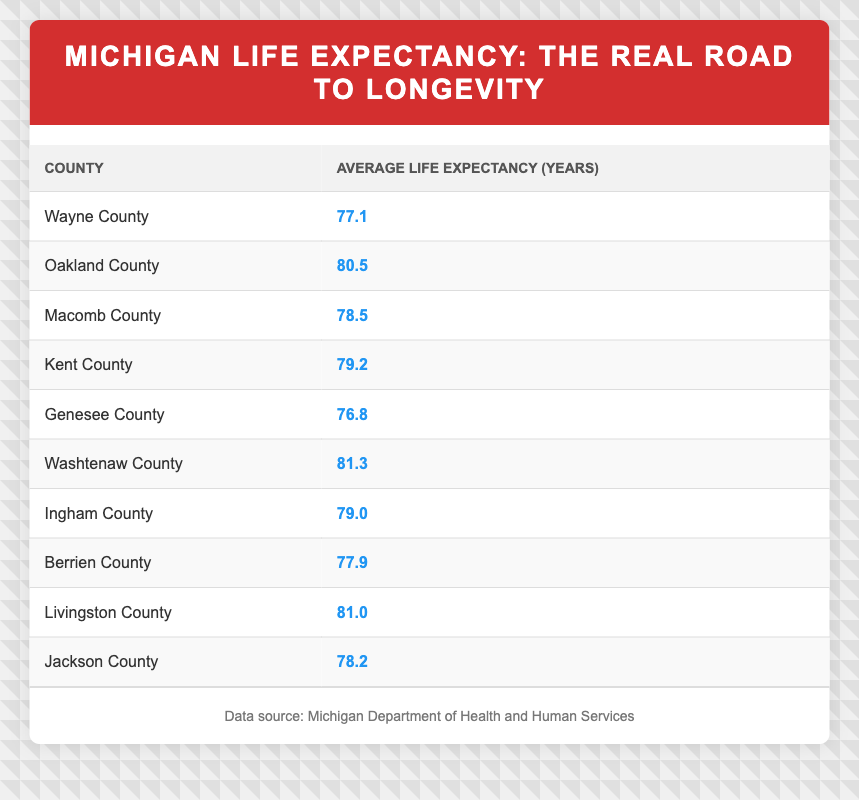What is the average life expectancy in Wayne County? The table states that the average life expectancy for Wayne County is 77.1 years.
Answer: 77.1 How does the average life expectancy in Oakland County compare to that in Genesee County? Oakland County has an average life expectancy of 80.5 years, while Genesee County has 76.8 years, which shows that Oakland County's life expectancy is higher by 3.7 years.
Answer: Higher by 3.7 years Which county has the highest average life expectancy? According to the table, Washtenaw County has the highest average life expectancy at 81.3 years.
Answer: 81.3 What is the difference in average life expectancy between Livingston County and Macomb County? Livingston County has an average life expectancy of 81.0 years, while Macomb County has 78.5 years. The difference is calculated as 81.0 - 78.5 = 2.5 years.
Answer: 2.5 Is the average life expectancy in Jackson County above or below the state average of 79.2 years? Jackson County's average life expectancy is 78.2 years, which is below the average of 79.2 years.
Answer: Below Calculate the average life expectancy of the counties represented in the table. To find the average, add up the life expectancies: (77.1 + 80.5 + 78.5 + 79.2 + 76.8 + 81.3 + 79.0 + 77.9 + 81.0 + 78.2) =  794.5. There are 10 counties, so the average is 794.5/10 = 79.45 years.
Answer: 79.45 Are average life expectancies in the counties of Berrien and Ingham equal? Berrien County has an average life expectancy of 77.9 years, while Ingham County has 79.0 years, which are not equal.
Answer: No Which counties have an average life expectancy of 79 years or more? Looking at the table, the counties are Oakland (80.5), Washtenaw (81.3), Livingston (81.0), Kent (79.2), and Ingham (79.0).
Answer: Oakland, Washtenaw, Livingston, Kent, Ingham 